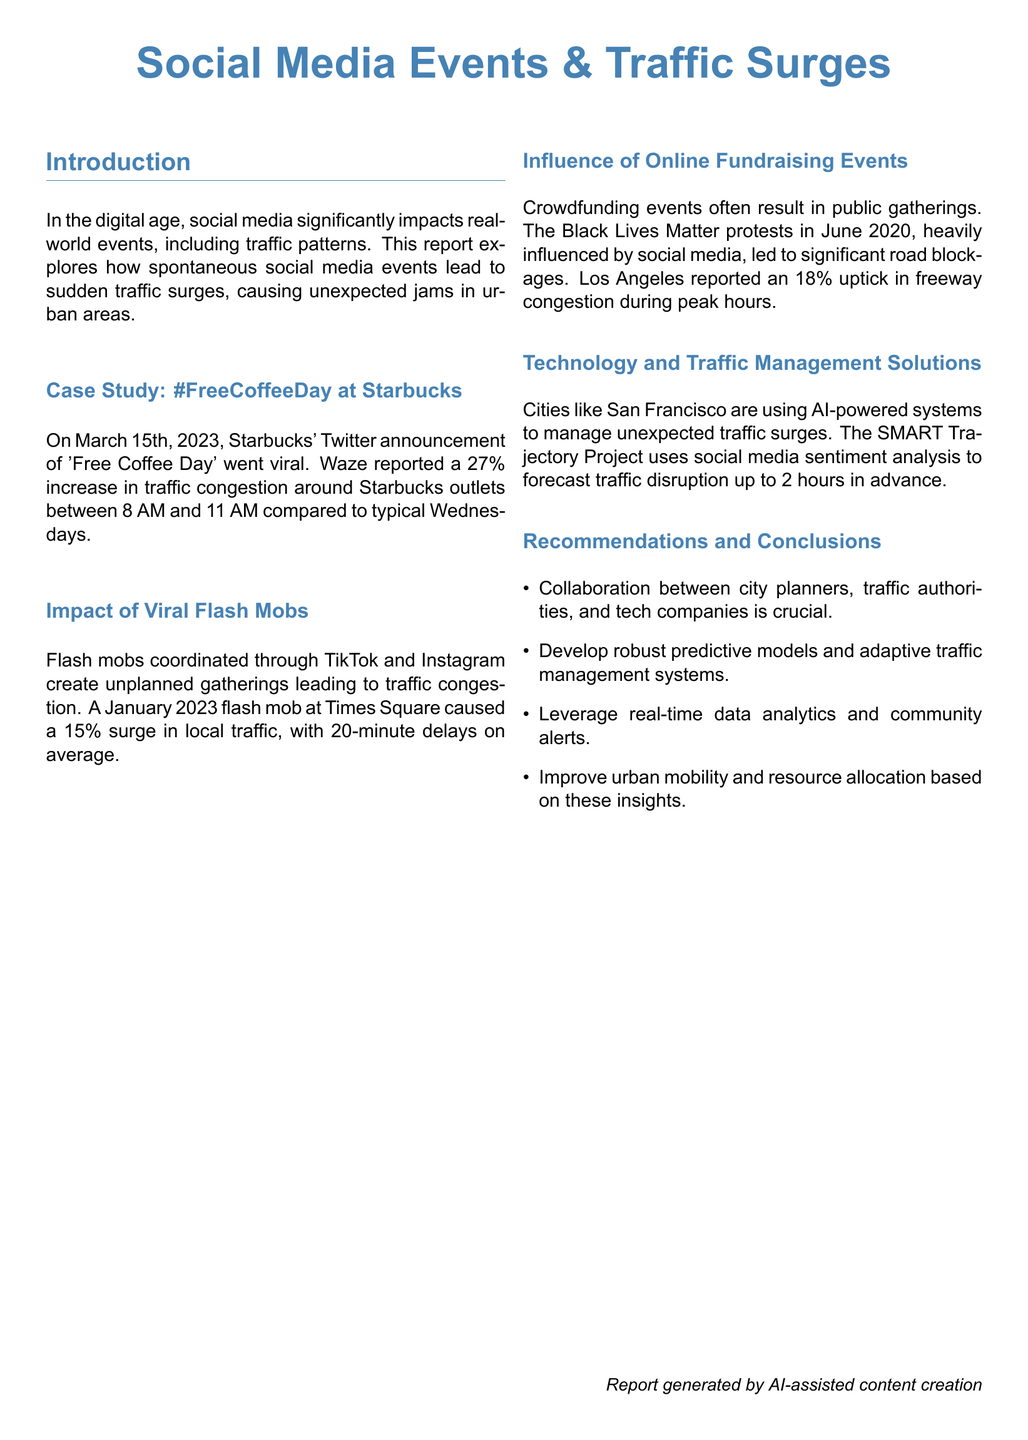what is the main topic of the report? The report focuses on how social media events impact traffic patterns, particularly on spontaneous traffic surges causing jams.
Answer: Social Media Events & Traffic Surges when did the Starbucks #FreeCoffeeDay event occur? The event of 'Free Coffee Day' at Starbucks took place on March 15th, 2023.
Answer: March 15th, 2023 what percentage increase in traffic congestion was reported during the Starbucks event? Waze reported a 27% increase in traffic congestion around Starbucks outlets during the event.
Answer: 27% what was the average delay caused by the January 2023 flash mob at Times Square? The average delay caused by the flash mob at Times Square was 20 minutes.
Answer: 20 minutes which city is using AI-powered systems to manage traffic surges? San Francisco is using AI-powered systems for traffic management.
Answer: San Francisco what type of events led to an 18% uptick in freeway congestion in Los Angeles? Crowdfunding events and public gatherings led to the 18% uptick in congestion.
Answer: Crowdfunding events what is a recommendation mentioned for improving urban mobility? A recommendation is to leverage real-time data analytics and community alerts to improve urban mobility.
Answer: Leverage real-time data analytics how much congestion increase was reported during the Black Lives Matter protests? The protests led to an 18% uptick in freeway congestion during peak hours.
Answer: 18% what is the SMART Trajectory Project? The SMART Trajectory Project is an AI-powered system that uses social media sentiment analysis to forecast traffic disruption.
Answer: AI-powered system 